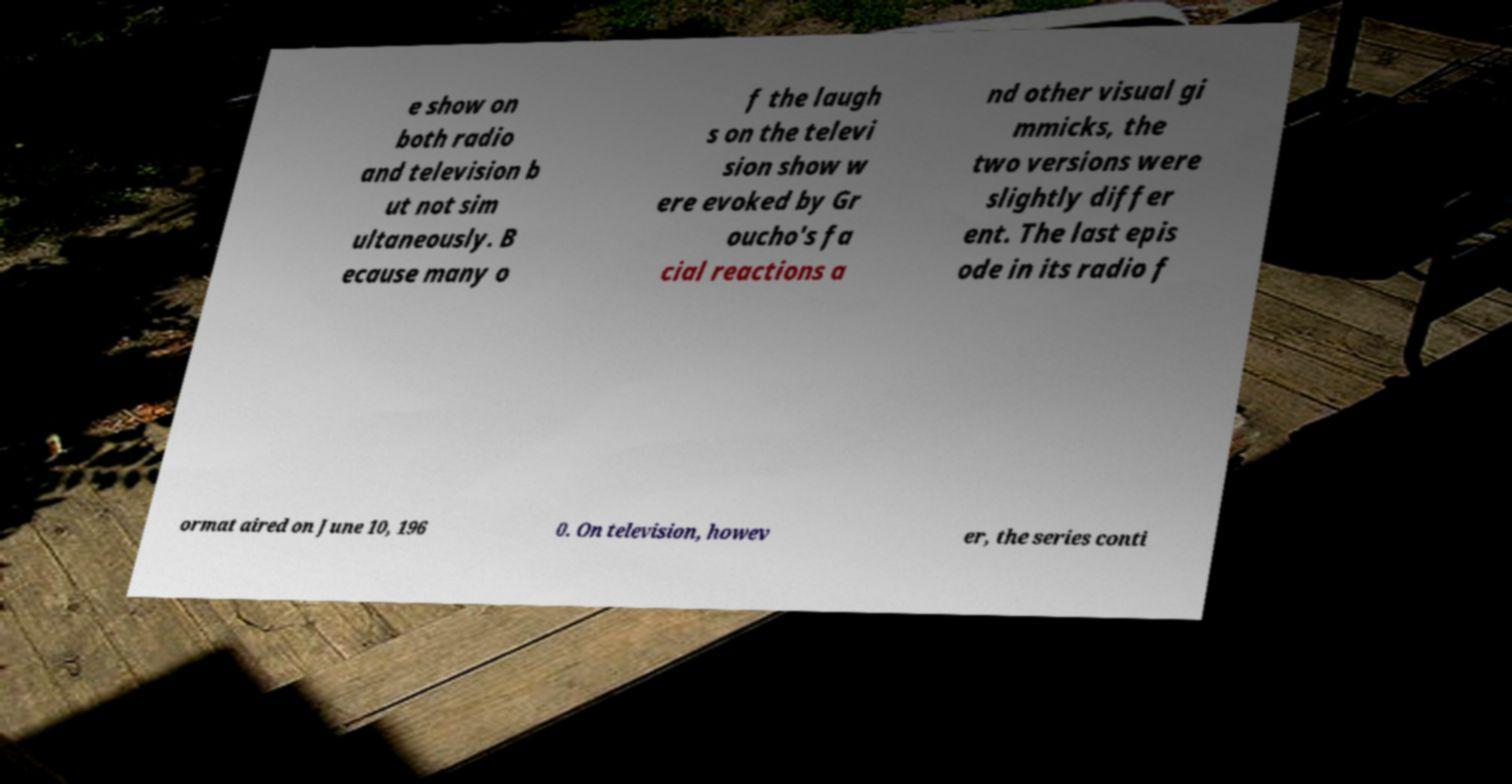Can you accurately transcribe the text from the provided image for me? e show on both radio and television b ut not sim ultaneously. B ecause many o f the laugh s on the televi sion show w ere evoked by Gr oucho's fa cial reactions a nd other visual gi mmicks, the two versions were slightly differ ent. The last epis ode in its radio f ormat aired on June 10, 196 0. On television, howev er, the series conti 